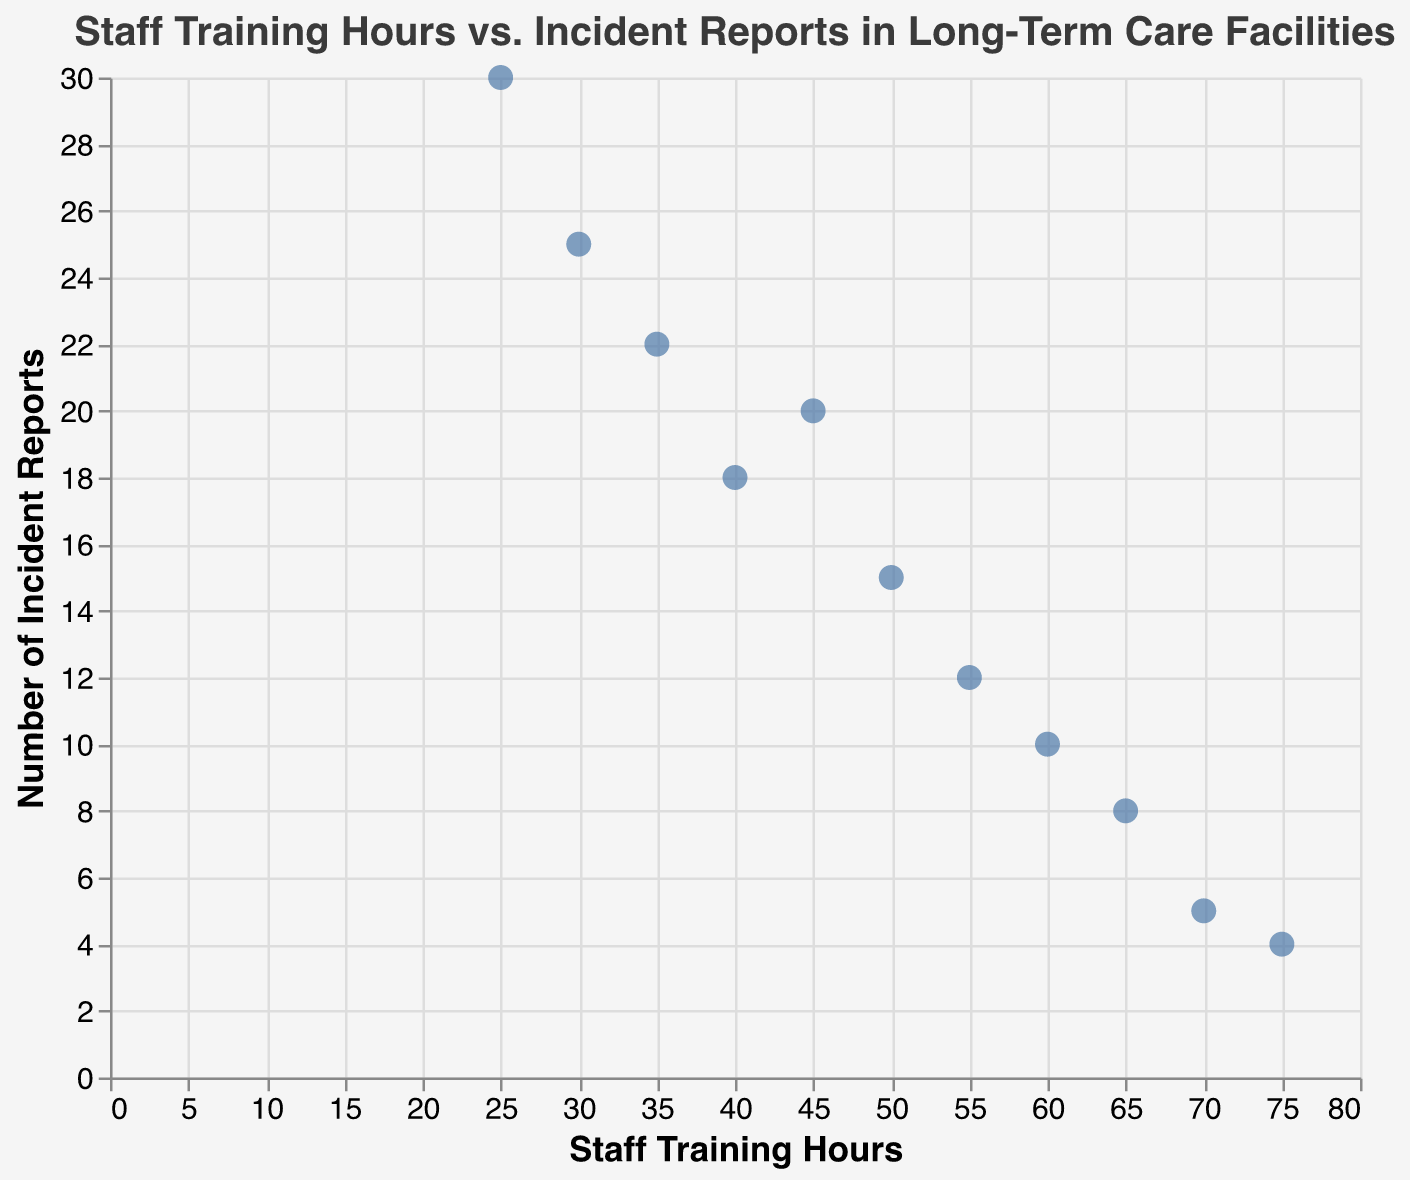What's the title of the figure? To identify the title, look at the top of the scatter plot where it is prominently displayed.
Answer: "Staff Training Hours vs. Incident Reports in Long-Term Care Facilities" How many data points are plotted on the scatter plot? Count each point representing a facility on the scatter plot.
Answer: 11 Which facility has the highest number of incident reports? Look for the point with the highest value on the y-axis and check the tooltip or label for the facility name.
Answer: Evergreen Nursing Facility Which facility has the highest number of staff training hours? Look for the point farthest to the right on the x-axis and check the tooltip or label for the facility name.
Answer: Lakeside Long-Term Care What is the range of staff training hours across the facilities? Identify the minimum and maximum values on the x-axis to determine the range.
Answer: 25 to 75 hours Is there a visible trend between staff training hours and incident reports? Observe the overall direction of the points; if a downward trend is noticeable, we can infer a negative correlation.
Answer: Yes, there seems to be a negative correlation What is the difference in incident reports between Green Valley Assisted Living and Harmony Care Center? Locate the y-values for both facilities and compute the difference. Green Valley Assisted Living has 10 incident reports and Harmony Care Center has 20. So, the difference is 20 - 10.
Answer: 10 On average, do facilities with more staff training hours have fewer incident reports? Analyze the scatter plot to see if points with higher x-values generally have lower y-values, indicating a negative correlation.
Answer: Yes Which facility has a notable outlier in terms of incident reports with relatively low staff training hours? Check for points that deviate significantly from the trend; Silver Oaks Elder Care has high incident reports with low training hours.
Answer: Silver Oaks Elder Care 